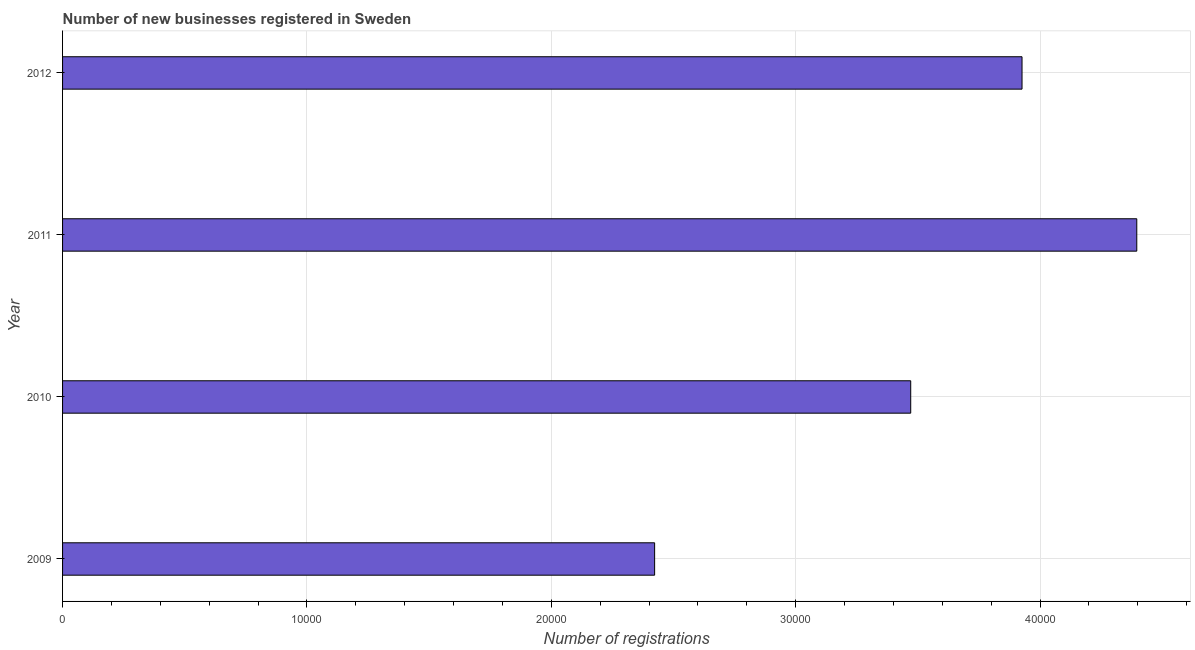Does the graph contain any zero values?
Your answer should be compact. No. What is the title of the graph?
Your answer should be compact. Number of new businesses registered in Sweden. What is the label or title of the X-axis?
Provide a short and direct response. Number of registrations. What is the number of new business registrations in 2009?
Your answer should be compact. 2.42e+04. Across all years, what is the maximum number of new business registrations?
Give a very brief answer. 4.40e+04. Across all years, what is the minimum number of new business registrations?
Your response must be concise. 2.42e+04. What is the sum of the number of new business registrations?
Give a very brief answer. 1.42e+05. What is the difference between the number of new business registrations in 2009 and 2012?
Provide a short and direct response. -1.50e+04. What is the average number of new business registrations per year?
Make the answer very short. 3.55e+04. What is the median number of new business registrations?
Offer a terse response. 3.70e+04. In how many years, is the number of new business registrations greater than 20000 ?
Provide a succinct answer. 4. Do a majority of the years between 2011 and 2012 (inclusive) have number of new business registrations greater than 8000 ?
Offer a terse response. Yes. What is the ratio of the number of new business registrations in 2009 to that in 2012?
Your answer should be compact. 0.62. What is the difference between the highest and the second highest number of new business registrations?
Your answer should be compact. 4696. Is the sum of the number of new business registrations in 2009 and 2012 greater than the maximum number of new business registrations across all years?
Keep it short and to the point. Yes. What is the difference between the highest and the lowest number of new business registrations?
Make the answer very short. 1.97e+04. In how many years, is the number of new business registrations greater than the average number of new business registrations taken over all years?
Your answer should be compact. 2. Are all the bars in the graph horizontal?
Make the answer very short. Yes. How many years are there in the graph?
Offer a very short reply. 4. Are the values on the major ticks of X-axis written in scientific E-notation?
Your answer should be very brief. No. What is the Number of registrations of 2009?
Provide a short and direct response. 2.42e+04. What is the Number of registrations in 2010?
Your answer should be very brief. 3.47e+04. What is the Number of registrations of 2011?
Give a very brief answer. 4.40e+04. What is the Number of registrations of 2012?
Your response must be concise. 3.93e+04. What is the difference between the Number of registrations in 2009 and 2010?
Your answer should be very brief. -1.05e+04. What is the difference between the Number of registrations in 2009 and 2011?
Provide a short and direct response. -1.97e+04. What is the difference between the Number of registrations in 2009 and 2012?
Give a very brief answer. -1.50e+04. What is the difference between the Number of registrations in 2010 and 2011?
Offer a terse response. -9251. What is the difference between the Number of registrations in 2010 and 2012?
Offer a very short reply. -4555. What is the difference between the Number of registrations in 2011 and 2012?
Make the answer very short. 4696. What is the ratio of the Number of registrations in 2009 to that in 2010?
Your answer should be very brief. 0.7. What is the ratio of the Number of registrations in 2009 to that in 2011?
Offer a terse response. 0.55. What is the ratio of the Number of registrations in 2009 to that in 2012?
Provide a succinct answer. 0.62. What is the ratio of the Number of registrations in 2010 to that in 2011?
Provide a succinct answer. 0.79. What is the ratio of the Number of registrations in 2010 to that in 2012?
Your response must be concise. 0.88. What is the ratio of the Number of registrations in 2011 to that in 2012?
Your answer should be very brief. 1.12. 